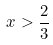<formula> <loc_0><loc_0><loc_500><loc_500>x > \frac { 2 } { 3 }</formula> 